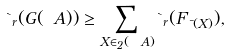<formula> <loc_0><loc_0><loc_500><loc_500>\theta _ { r } ( G ( \ A ) ) \geq \sum _ { X \in \L _ { 2 } ( \ A ) } \theta _ { r } ( F _ { \mu ( X ) } ) ,</formula> 